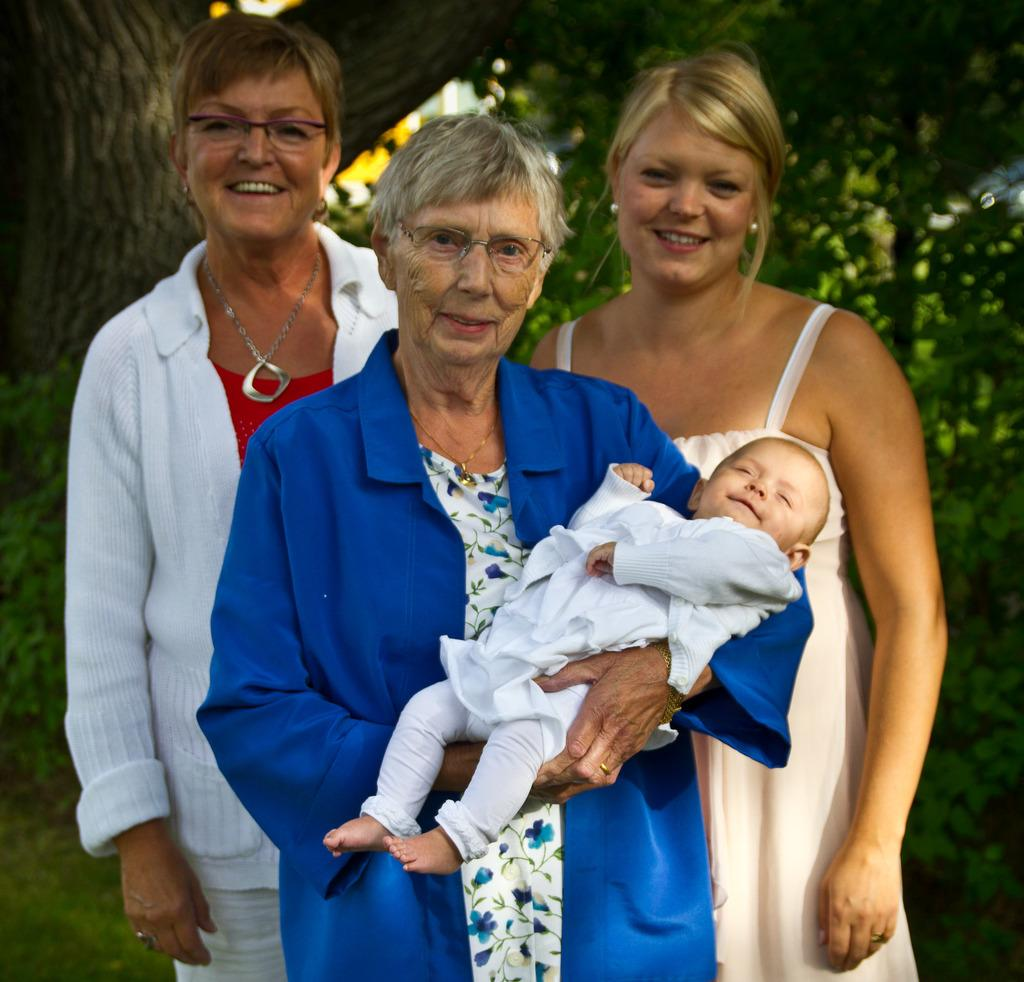How many people are present in the image? There are four people in the image. What can be observed about the clothing of the people in the image? The people are wearing different color dresses. What type of natural scenery is visible in the background of the image? There are trees in the background of the image. How many eggs are sitting on the spot in the image? There are no eggs or spots present in the image. 